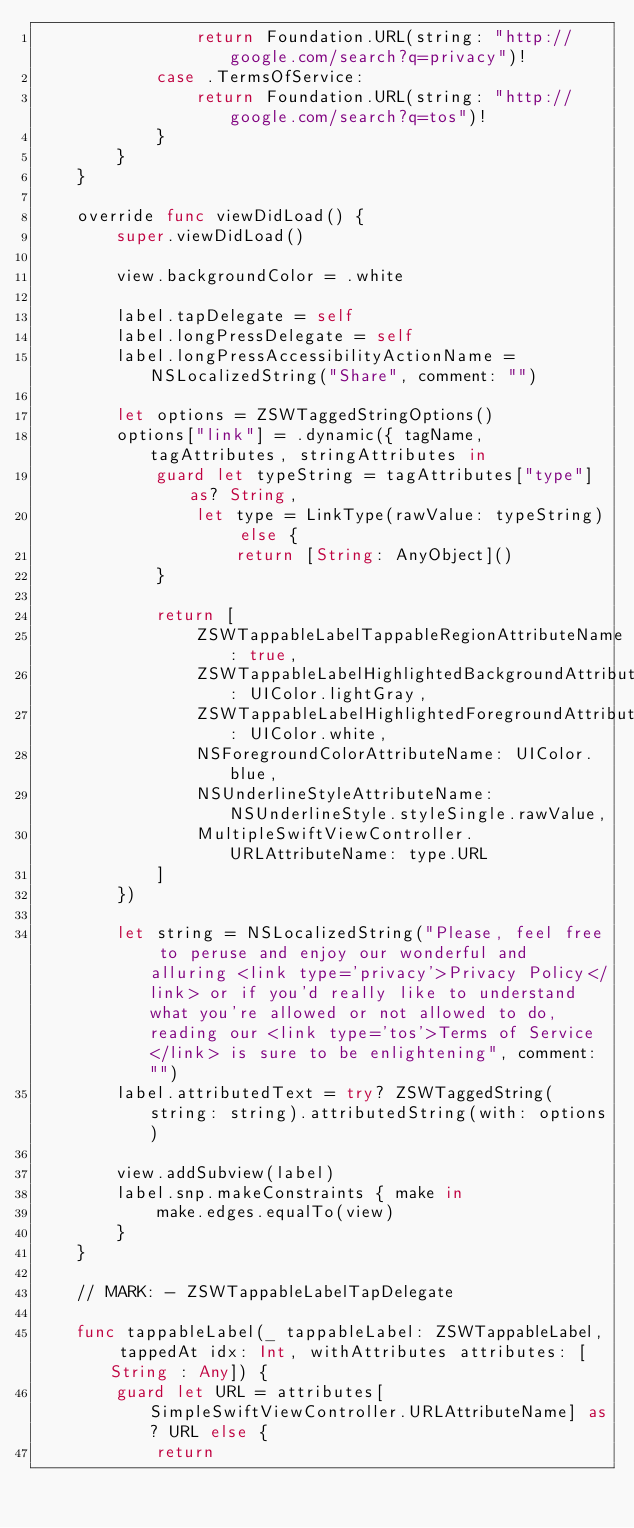<code> <loc_0><loc_0><loc_500><loc_500><_Swift_>                return Foundation.URL(string: "http://google.com/search?q=privacy")!
            case .TermsOfService:
                return Foundation.URL(string: "http://google.com/search?q=tos")!
            }
        }
    }
    
    override func viewDidLoad() {
        super.viewDidLoad()
        
        view.backgroundColor = .white
        
        label.tapDelegate = self
        label.longPressDelegate = self
        label.longPressAccessibilityActionName = NSLocalizedString("Share", comment: "")
        
        let options = ZSWTaggedStringOptions()
        options["link"] = .dynamic({ tagName, tagAttributes, stringAttributes in
            guard let typeString = tagAttributes["type"] as? String,
                let type = LinkType(rawValue: typeString) else {
                    return [String: AnyObject]()
            }
            
            return [
                ZSWTappableLabelTappableRegionAttributeName: true,
                ZSWTappableLabelHighlightedBackgroundAttributeName: UIColor.lightGray,
                ZSWTappableLabelHighlightedForegroundAttributeName: UIColor.white,
                NSForegroundColorAttributeName: UIColor.blue,
                NSUnderlineStyleAttributeName: NSUnderlineStyle.styleSingle.rawValue,
                MultipleSwiftViewController.URLAttributeName: type.URL
            ]
        })
        
        let string = NSLocalizedString("Please, feel free to peruse and enjoy our wonderful and alluring <link type='privacy'>Privacy Policy</link> or if you'd really like to understand what you're allowed or not allowed to do, reading our <link type='tos'>Terms of Service</link> is sure to be enlightening", comment: "")
        label.attributedText = try? ZSWTaggedString(string: string).attributedString(with: options)
        
        view.addSubview(label)
        label.snp.makeConstraints { make in
            make.edges.equalTo(view)
        }
    }
    
    // MARK: - ZSWTappableLabelTapDelegate
    
    func tappableLabel(_ tappableLabel: ZSWTappableLabel, tappedAt idx: Int, withAttributes attributes: [String : Any]) {
        guard let URL = attributes[SimpleSwiftViewController.URLAttributeName] as? URL else {
            return</code> 